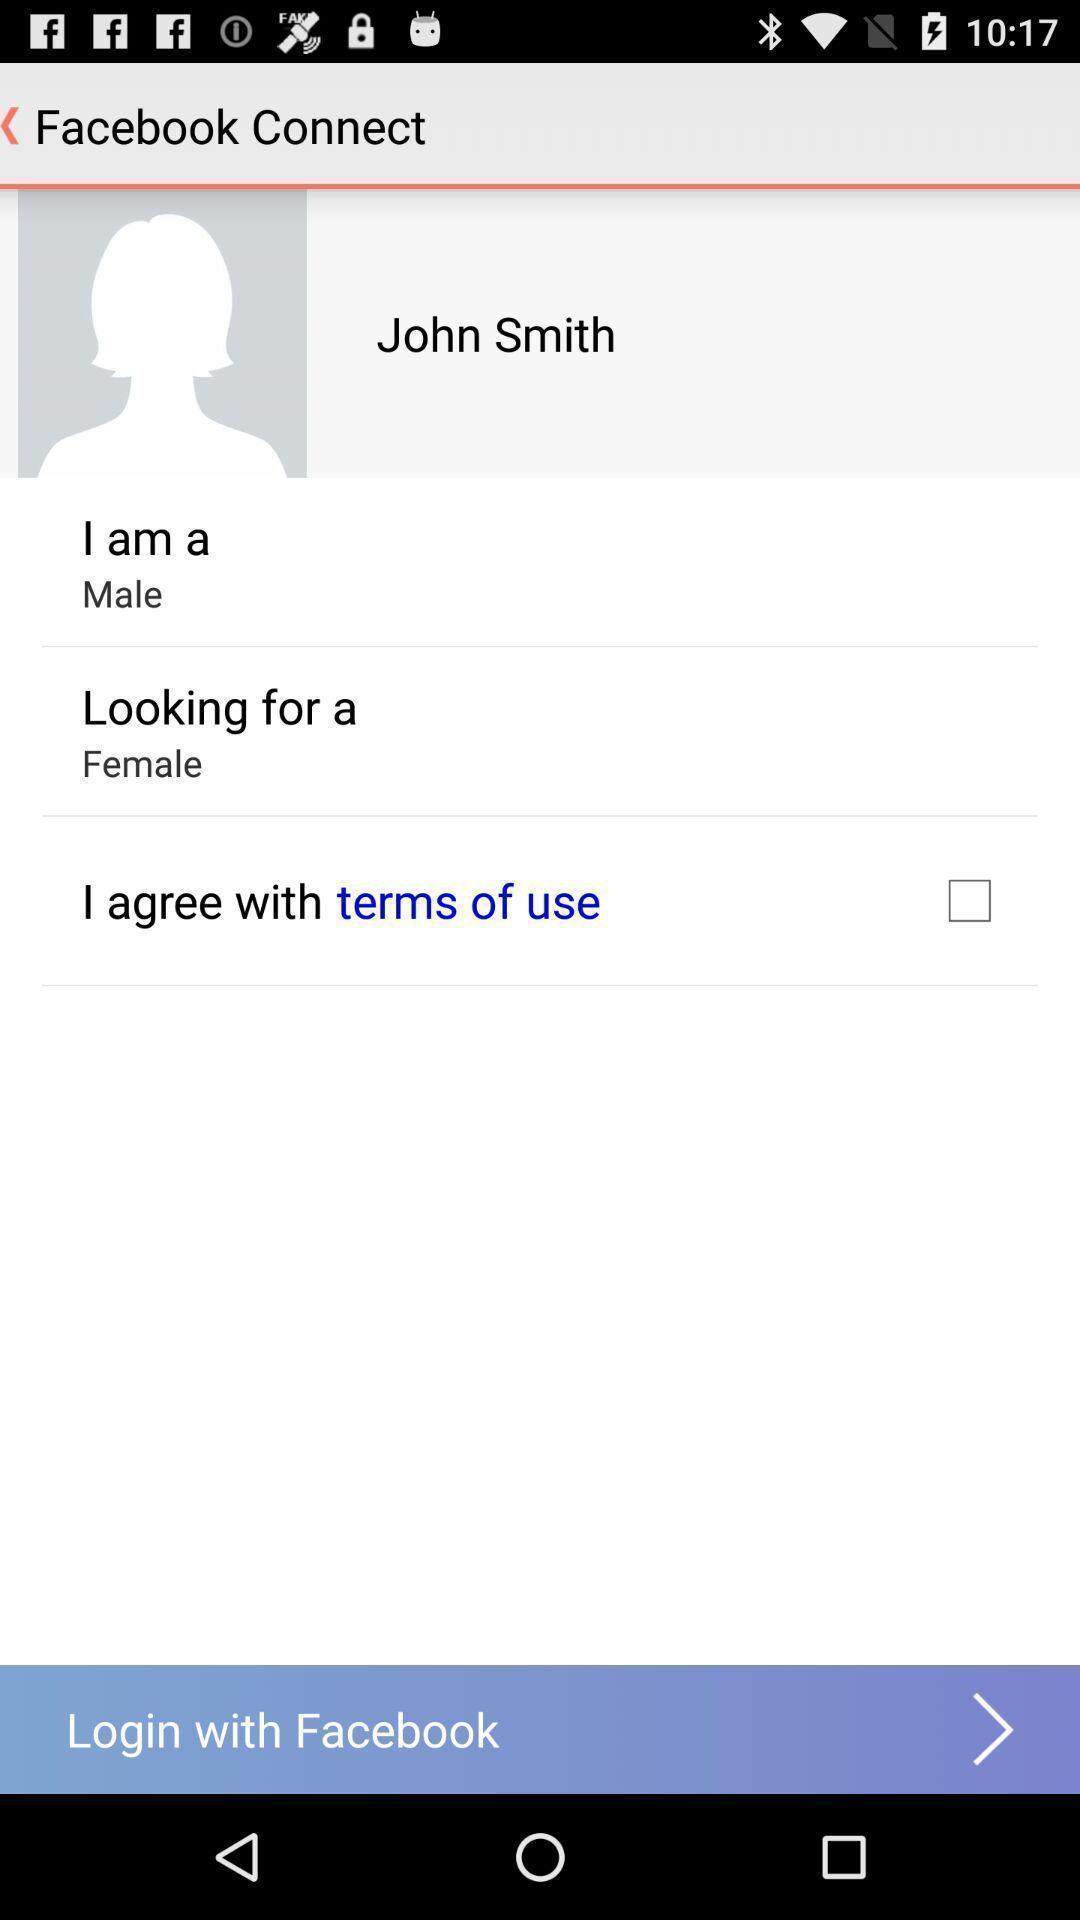Explain what's happening in this screen capture. Terms agreement page for login in a social app. 